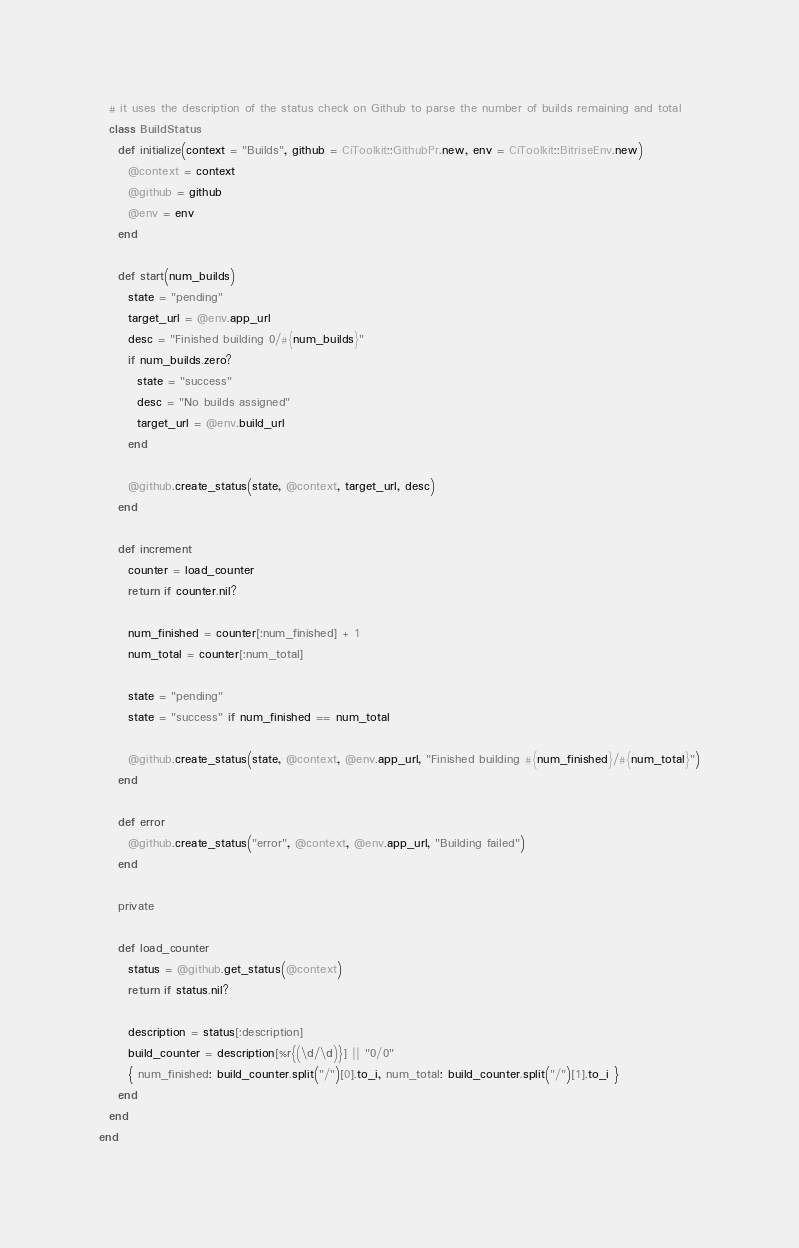<code> <loc_0><loc_0><loc_500><loc_500><_Ruby_>  # it uses the description of the status check on Github to parse the number of builds remaining and total
  class BuildStatus
    def initialize(context = "Builds", github = CiToolkit::GithubPr.new, env = CiToolkit::BitriseEnv.new)
      @context = context
      @github = github
      @env = env
    end

    def start(num_builds)
      state = "pending"
      target_url = @env.app_url
      desc = "Finished building 0/#{num_builds}"
      if num_builds.zero?
        state = "success"
        desc = "No builds assigned"
        target_url = @env.build_url
      end

      @github.create_status(state, @context, target_url, desc)
    end

    def increment
      counter = load_counter
      return if counter.nil?

      num_finished = counter[:num_finished] + 1
      num_total = counter[:num_total]

      state = "pending"
      state = "success" if num_finished == num_total

      @github.create_status(state, @context, @env.app_url, "Finished building #{num_finished}/#{num_total}")
    end

    def error
      @github.create_status("error", @context, @env.app_url, "Building failed")
    end

    private

    def load_counter
      status = @github.get_status(@context)
      return if status.nil?

      description = status[:description]
      build_counter = description[%r{(\d/\d)}] || "0/0"
      { num_finished: build_counter.split("/")[0].to_i, num_total: build_counter.split("/")[1].to_i }
    end
  end
end
</code> 